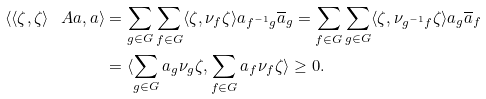<formula> <loc_0><loc_0><loc_500><loc_500>\langle \langle \zeta , \zeta \rangle _ { \ } A a , a \rangle & = \sum _ { g \in G } \sum _ { f \in G } \langle \zeta , \nu _ { f } \zeta \rangle a _ { f ^ { - 1 } g } \overline { a } _ { g } = \sum _ { f \in G } \sum _ { g \in G } \langle \zeta , \nu _ { g ^ { - 1 } f } \zeta \rangle a _ { g } \overline { a } _ { f } \\ & = \langle \sum _ { g \in G } a _ { g } \nu _ { g } \zeta , \sum _ { f \in G } a _ { f } \nu _ { f } \zeta \rangle \geq 0 .</formula> 